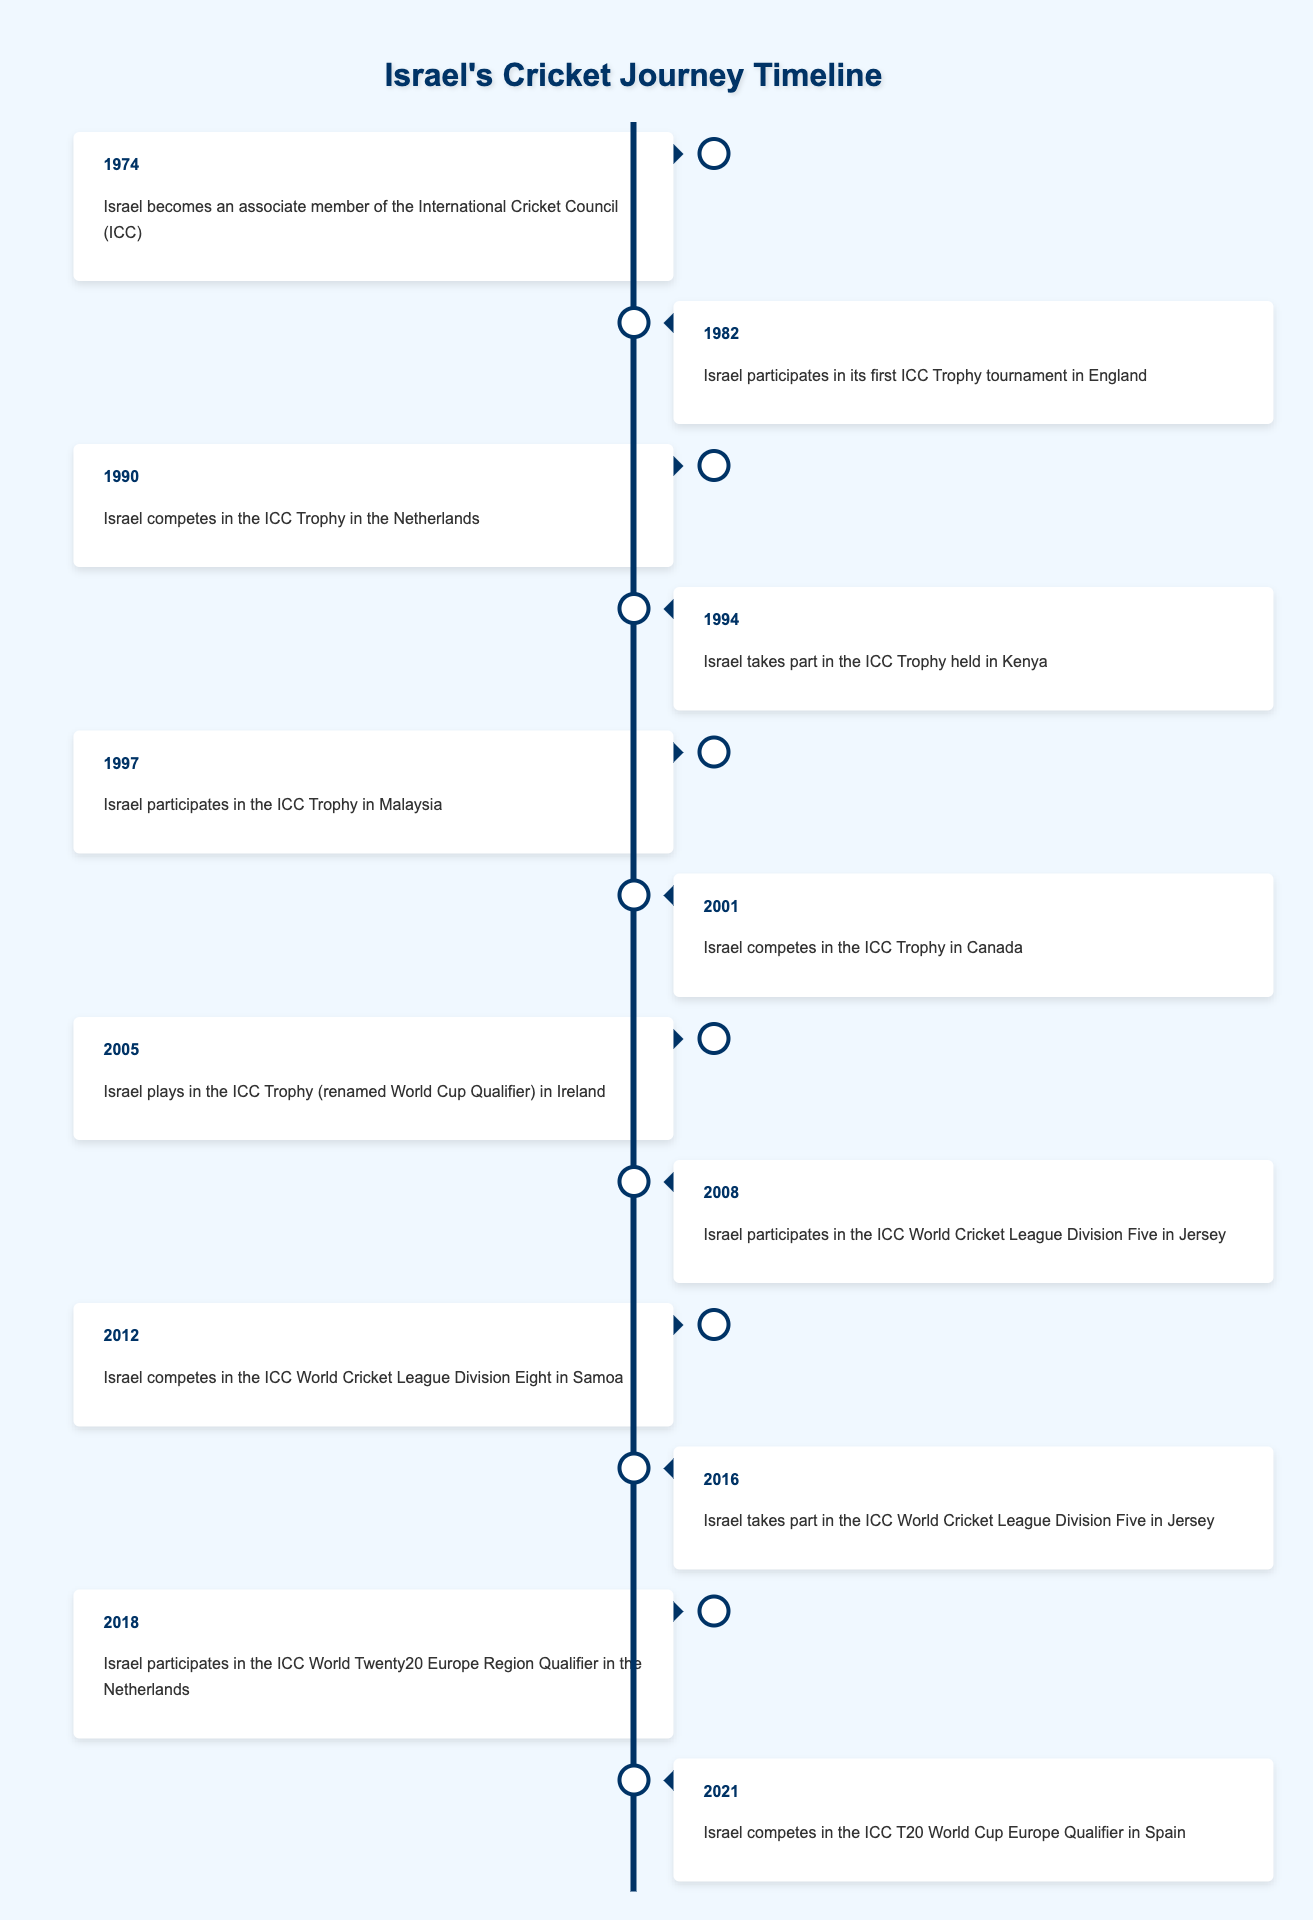What year did Israel become an associate member of the ICC? The table lists the year 1974 as the event when Israel became an associate member of the International Cricket Council (ICC).
Answer: 1974 How many times did Israel participate in the ICC Trophy between 1982 and 2005? Between 1982 and 2005, Israel participated in the ICC Trophy a total of five times: 1982, 1990, 1994, 1997, and 2001.
Answer: 5 Did Israel compete in any international cricket tournaments in the year 2016? Yes, according to the table, Israel took part in the ICC World Cricket League Division Five in Jersey in 2016.
Answer: Yes Which tournament did Israel participate in just after the ICC Trophy was renamed to World Cup Qualifier? The ICC Trophy was renamed the World Cup Qualifier after 2005, and Israel participated in the World Cup Qualifier in Ireland in 2005. This was right after the ICC Trophy's renaming.
Answer: World Cup Qualifier in Ireland In which years did Israel participate in tournaments held in Jersey? Israel participated in the ICC World Cricket League Division Five in Jersey in two years: 2008 and 2016. Both entries are noted in the table under those respective years.
Answer: 2008, 2016 Was Israel's first participation in the ICC Trophy before or after it became an ICC associate member? Israel's first participation in the ICC Trophy was in 1982, which is after it became an ICC associate member in 1974. Therefore, it was after.
Answer: After What percentage of events listed occurred in the 2000s (2000-2009)? There are five events from the 2000s (2001, 2005, 2008) out of a total of 12 events listed. To find the percentage, we compute (5/12) * 100 ≈ 41.67%. Thus, approximately 41.67% of events occurred in the 2000s.
Answer: Approximately 41.67% How many years passed between Israel's first ICC Trophy participation and its last listed tournament? The first ICC Trophy participation was in 1982, and the last listed tournament is in 2021. To calculate the difference: 2021 - 1982 = 39 years.
Answer: 39 years 